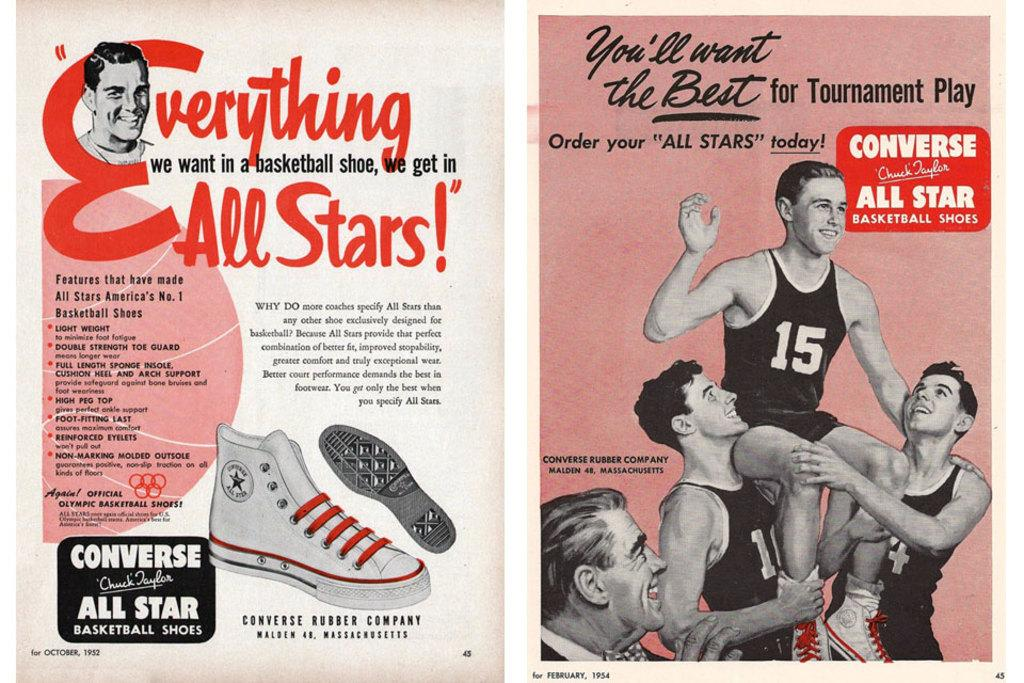What can be found in the foreground of the poster? There is text in the foreground of the poster. What is depicted on the left side of the poster? There is an image of shoes and a person on the left side of the poster. What is present on the right side of the poster? There are people and text on the right side of the poster. What type of produce is being sold by the person in the image on the left side of the poster? There is no produce present in the image; it features an image of shoes and a person. How many zebras can be seen on the right side of the poster? There are no zebras present on the poster; it features people and text. 